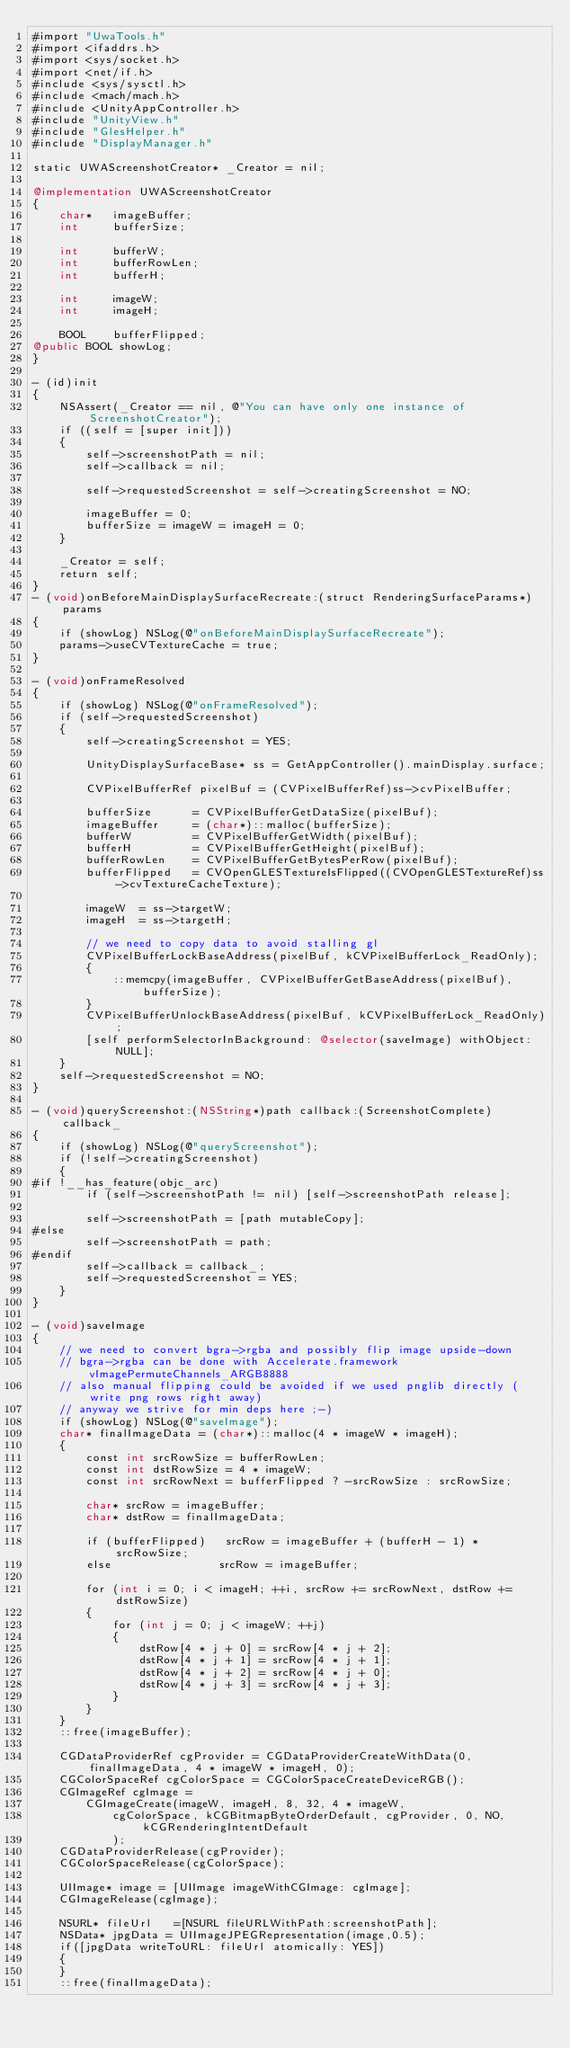<code> <loc_0><loc_0><loc_500><loc_500><_ObjectiveC_>#import "UwaTools.h"
#import <ifaddrs.h>
#import <sys/socket.h>
#import <net/if.h>
#include <sys/sysctl.h>
#include <mach/mach.h>
#include <UnityAppController.h>
#include "UnityView.h"
#include "GlesHelper.h"
#include "DisplayManager.h"

static UWAScreenshotCreator* _Creator = nil;

@implementation UWAScreenshotCreator
{
    char*   imageBuffer;
    int     bufferSize;

    int     bufferW;
    int     bufferRowLen;
    int     bufferH;

    int     imageW;
    int     imageH;

    BOOL    bufferFlipped;
@public BOOL showLog;
}

- (id)init
{
    NSAssert(_Creator == nil, @"You can have only one instance of ScreenshotCreator");
    if ((self = [super init]))
    {
        self->screenshotPath = nil;
        self->callback = nil;

        self->requestedScreenshot = self->creatingScreenshot = NO;

        imageBuffer = 0;
        bufferSize = imageW = imageH = 0;
    }

    _Creator = self;
    return self;
}
- (void)onBeforeMainDisplaySurfaceRecreate:(struct RenderingSurfaceParams*)params
{
    if (showLog) NSLog(@"onBeforeMainDisplaySurfaceRecreate");
    params->useCVTextureCache = true;
}

- (void)onFrameResolved
{
    if (showLog) NSLog(@"onFrameResolved");
    if (self->requestedScreenshot)
    {
        self->creatingScreenshot = YES;

        UnityDisplaySurfaceBase* ss = GetAppController().mainDisplay.surface;
        
        CVPixelBufferRef pixelBuf = (CVPixelBufferRef)ss->cvPixelBuffer;

        bufferSize      = CVPixelBufferGetDataSize(pixelBuf);
        imageBuffer     = (char*)::malloc(bufferSize);
        bufferW         = CVPixelBufferGetWidth(pixelBuf);
        bufferH         = CVPixelBufferGetHeight(pixelBuf);
        bufferRowLen    = CVPixelBufferGetBytesPerRow(pixelBuf);
        bufferFlipped   = CVOpenGLESTextureIsFlipped((CVOpenGLESTextureRef)ss->cvTextureCacheTexture);

        imageW  = ss->targetW;
        imageH  = ss->targetH;

        // we need to copy data to avoid stalling gl
        CVPixelBufferLockBaseAddress(pixelBuf, kCVPixelBufferLock_ReadOnly);
        {
            ::memcpy(imageBuffer, CVPixelBufferGetBaseAddress(pixelBuf), bufferSize);
        }
        CVPixelBufferUnlockBaseAddress(pixelBuf, kCVPixelBufferLock_ReadOnly);
        [self performSelectorInBackground: @selector(saveImage) withObject: NULL];
    }
    self->requestedScreenshot = NO;
}

- (void)queryScreenshot:(NSString*)path callback:(ScreenshotComplete)callback_
{
    if (showLog) NSLog(@"queryScreenshot");
    if (!self->creatingScreenshot)
    {
#if !__has_feature(objc_arc)
        if (self->screenshotPath != nil) [self->screenshotPath release];
        
        self->screenshotPath = [path mutableCopy];
#else
        self->screenshotPath = path;
#endif
        self->callback = callback_;
        self->requestedScreenshot = YES;
    }
}

- (void)saveImage
{
    // we need to convert bgra->rgba and possibly flip image upside-down
    // bgra->rgba can be done with Accelerate.framework vImagePermuteChannels_ARGB8888
    // also manual flipping could be avoided if we used pnglib directly (write png rows right away)
    // anyway we strive for min deps here ;-)
    if (showLog) NSLog(@"saveImage");
    char* finalImageData = (char*)::malloc(4 * imageW * imageH);
    {
        const int srcRowSize = bufferRowLen;
        const int dstRowSize = 4 * imageW;
        const int srcRowNext = bufferFlipped ? -srcRowSize : srcRowSize;

        char* srcRow = imageBuffer;
        char* dstRow = finalImageData;

        if (bufferFlipped)   srcRow = imageBuffer + (bufferH - 1) * srcRowSize;
        else                srcRow = imageBuffer;

        for (int i = 0; i < imageH; ++i, srcRow += srcRowNext, dstRow += dstRowSize)
        {
            for (int j = 0; j < imageW; ++j)
            {
                dstRow[4 * j + 0] = srcRow[4 * j + 2];
                dstRow[4 * j + 1] = srcRow[4 * j + 1];
                dstRow[4 * j + 2] = srcRow[4 * j + 0];
                dstRow[4 * j + 3] = srcRow[4 * j + 3];
            }
        }
    }
    ::free(imageBuffer);

    CGDataProviderRef cgProvider = CGDataProviderCreateWithData(0, finalImageData, 4 * imageW * imageH, 0);
    CGColorSpaceRef cgColorSpace = CGColorSpaceCreateDeviceRGB();
    CGImageRef cgImage =
        CGImageCreate(imageW, imageH, 8, 32, 4 * imageW,
            cgColorSpace, kCGBitmapByteOrderDefault, cgProvider, 0, NO, kCGRenderingIntentDefault
            );
    CGDataProviderRelease(cgProvider);
    CGColorSpaceRelease(cgColorSpace);

    UIImage* image = [UIImage imageWithCGImage: cgImage];
    CGImageRelease(cgImage);

    NSURL* fileUrl   =[NSURL fileURLWithPath:screenshotPath];
    NSData* jpgData = UIImageJPEGRepresentation(image,0.5);
    if([jpgData writeToURL: fileUrl atomically: YES])
    {
    }
    ::free(finalImageData);
</code> 